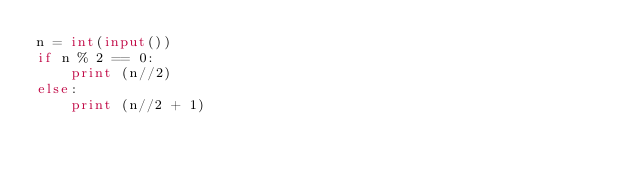Convert code to text. <code><loc_0><loc_0><loc_500><loc_500><_Python_>n = int(input())
if n % 2 == 0:
    print (n//2)
else:
    print (n//2 + 1)</code> 